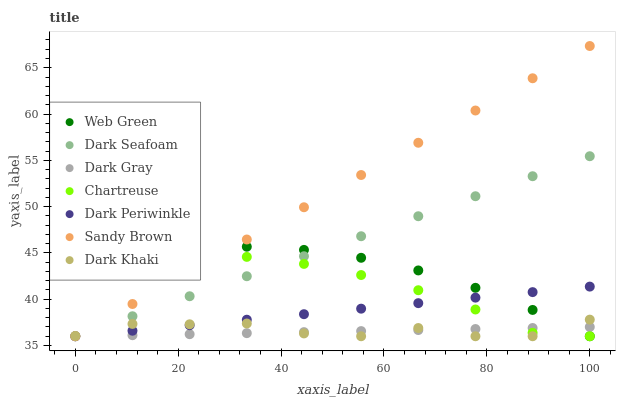Does Dark Gray have the minimum area under the curve?
Answer yes or no. Yes. Does Sandy Brown have the maximum area under the curve?
Answer yes or no. Yes. Does Chartreuse have the minimum area under the curve?
Answer yes or no. No. Does Chartreuse have the maximum area under the curve?
Answer yes or no. No. Is Dark Seafoam the smoothest?
Answer yes or no. Yes. Is Dark Khaki the roughest?
Answer yes or no. Yes. Is Chartreuse the smoothest?
Answer yes or no. No. Is Chartreuse the roughest?
Answer yes or no. No. Does Dark Khaki have the lowest value?
Answer yes or no. Yes. Does Sandy Brown have the highest value?
Answer yes or no. Yes. Does Chartreuse have the highest value?
Answer yes or no. No. Does Dark Gray intersect Sandy Brown?
Answer yes or no. Yes. Is Dark Gray less than Sandy Brown?
Answer yes or no. No. Is Dark Gray greater than Sandy Brown?
Answer yes or no. No. 